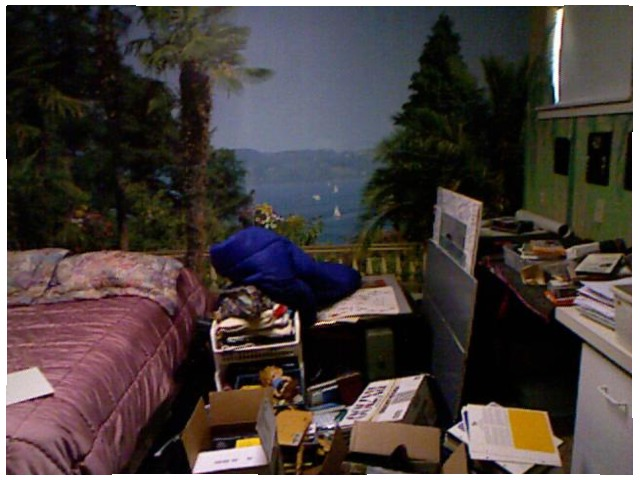<image>
Can you confirm if the tree is on the wall? Yes. Looking at the image, I can see the tree is positioned on top of the wall, with the wall providing support. Is the tree behind the bed? Yes. From this viewpoint, the tree is positioned behind the bed, with the bed partially or fully occluding the tree. Is the paper under the bed? No. The paper is not positioned under the bed. The vertical relationship between these objects is different. 